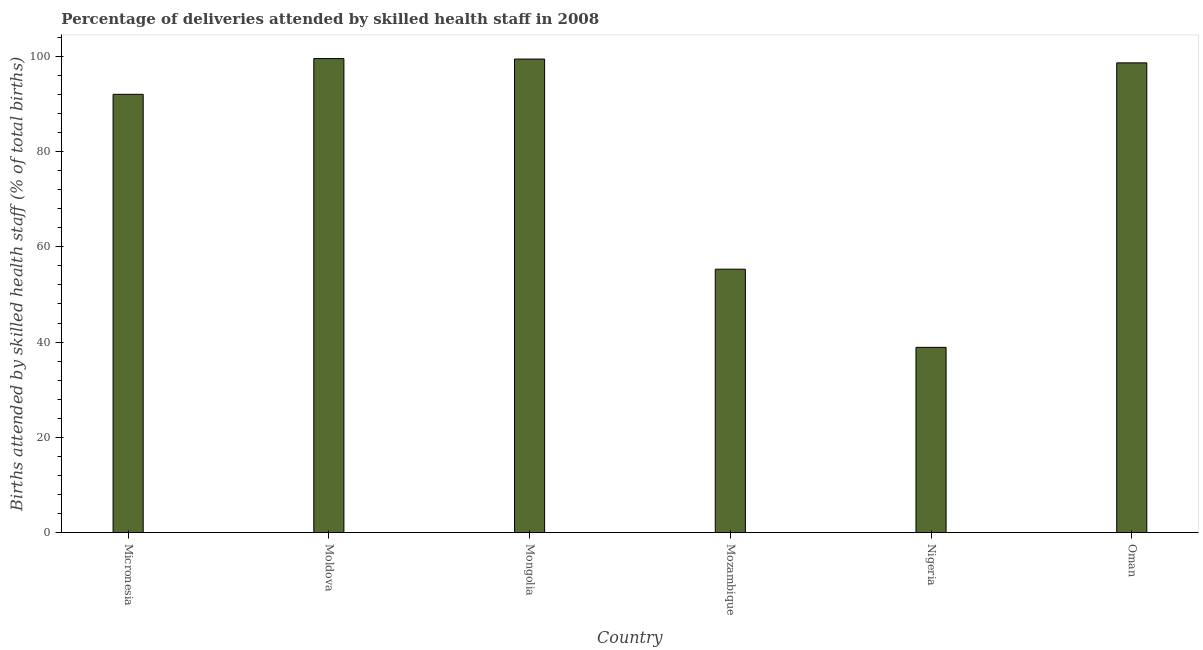Does the graph contain grids?
Provide a succinct answer. No. What is the title of the graph?
Keep it short and to the point. Percentage of deliveries attended by skilled health staff in 2008. What is the label or title of the Y-axis?
Offer a very short reply. Births attended by skilled health staff (% of total births). What is the number of births attended by skilled health staff in Micronesia?
Offer a terse response. 92. Across all countries, what is the maximum number of births attended by skilled health staff?
Offer a very short reply. 99.5. Across all countries, what is the minimum number of births attended by skilled health staff?
Keep it short and to the point. 38.9. In which country was the number of births attended by skilled health staff maximum?
Your answer should be compact. Moldova. In which country was the number of births attended by skilled health staff minimum?
Your response must be concise. Nigeria. What is the sum of the number of births attended by skilled health staff?
Provide a short and direct response. 483.7. What is the difference between the number of births attended by skilled health staff in Micronesia and Nigeria?
Offer a very short reply. 53.1. What is the average number of births attended by skilled health staff per country?
Your response must be concise. 80.62. What is the median number of births attended by skilled health staff?
Give a very brief answer. 95.3. What is the ratio of the number of births attended by skilled health staff in Mongolia to that in Oman?
Ensure brevity in your answer.  1.01. Is the difference between the number of births attended by skilled health staff in Micronesia and Mozambique greater than the difference between any two countries?
Keep it short and to the point. No. What is the difference between the highest and the lowest number of births attended by skilled health staff?
Keep it short and to the point. 60.6. In how many countries, is the number of births attended by skilled health staff greater than the average number of births attended by skilled health staff taken over all countries?
Make the answer very short. 4. How many bars are there?
Provide a succinct answer. 6. How many countries are there in the graph?
Offer a terse response. 6. Are the values on the major ticks of Y-axis written in scientific E-notation?
Keep it short and to the point. No. What is the Births attended by skilled health staff (% of total births) of Micronesia?
Your answer should be compact. 92. What is the Births attended by skilled health staff (% of total births) of Moldova?
Offer a terse response. 99.5. What is the Births attended by skilled health staff (% of total births) in Mongolia?
Offer a very short reply. 99.4. What is the Births attended by skilled health staff (% of total births) of Mozambique?
Provide a succinct answer. 55.3. What is the Births attended by skilled health staff (% of total births) of Nigeria?
Your answer should be very brief. 38.9. What is the Births attended by skilled health staff (% of total births) of Oman?
Offer a terse response. 98.6. What is the difference between the Births attended by skilled health staff (% of total births) in Micronesia and Moldova?
Your response must be concise. -7.5. What is the difference between the Births attended by skilled health staff (% of total births) in Micronesia and Mongolia?
Keep it short and to the point. -7.4. What is the difference between the Births attended by skilled health staff (% of total births) in Micronesia and Mozambique?
Provide a short and direct response. 36.7. What is the difference between the Births attended by skilled health staff (% of total births) in Micronesia and Nigeria?
Ensure brevity in your answer.  53.1. What is the difference between the Births attended by skilled health staff (% of total births) in Micronesia and Oman?
Your answer should be very brief. -6.6. What is the difference between the Births attended by skilled health staff (% of total births) in Moldova and Mongolia?
Provide a short and direct response. 0.1. What is the difference between the Births attended by skilled health staff (% of total births) in Moldova and Mozambique?
Ensure brevity in your answer.  44.2. What is the difference between the Births attended by skilled health staff (% of total births) in Moldova and Nigeria?
Keep it short and to the point. 60.6. What is the difference between the Births attended by skilled health staff (% of total births) in Moldova and Oman?
Provide a succinct answer. 0.9. What is the difference between the Births attended by skilled health staff (% of total births) in Mongolia and Mozambique?
Give a very brief answer. 44.1. What is the difference between the Births attended by skilled health staff (% of total births) in Mongolia and Nigeria?
Your answer should be compact. 60.5. What is the difference between the Births attended by skilled health staff (% of total births) in Mozambique and Nigeria?
Make the answer very short. 16.4. What is the difference between the Births attended by skilled health staff (% of total births) in Mozambique and Oman?
Provide a short and direct response. -43.3. What is the difference between the Births attended by skilled health staff (% of total births) in Nigeria and Oman?
Give a very brief answer. -59.7. What is the ratio of the Births attended by skilled health staff (% of total births) in Micronesia to that in Moldova?
Offer a very short reply. 0.93. What is the ratio of the Births attended by skilled health staff (% of total births) in Micronesia to that in Mongolia?
Give a very brief answer. 0.93. What is the ratio of the Births attended by skilled health staff (% of total births) in Micronesia to that in Mozambique?
Offer a very short reply. 1.66. What is the ratio of the Births attended by skilled health staff (% of total births) in Micronesia to that in Nigeria?
Your answer should be compact. 2.37. What is the ratio of the Births attended by skilled health staff (% of total births) in Micronesia to that in Oman?
Your answer should be compact. 0.93. What is the ratio of the Births attended by skilled health staff (% of total births) in Moldova to that in Mongolia?
Provide a succinct answer. 1. What is the ratio of the Births attended by skilled health staff (% of total births) in Moldova to that in Mozambique?
Keep it short and to the point. 1.8. What is the ratio of the Births attended by skilled health staff (% of total births) in Moldova to that in Nigeria?
Ensure brevity in your answer.  2.56. What is the ratio of the Births attended by skilled health staff (% of total births) in Mongolia to that in Mozambique?
Provide a short and direct response. 1.8. What is the ratio of the Births attended by skilled health staff (% of total births) in Mongolia to that in Nigeria?
Give a very brief answer. 2.56. What is the ratio of the Births attended by skilled health staff (% of total births) in Mozambique to that in Nigeria?
Give a very brief answer. 1.42. What is the ratio of the Births attended by skilled health staff (% of total births) in Mozambique to that in Oman?
Give a very brief answer. 0.56. What is the ratio of the Births attended by skilled health staff (% of total births) in Nigeria to that in Oman?
Give a very brief answer. 0.4. 